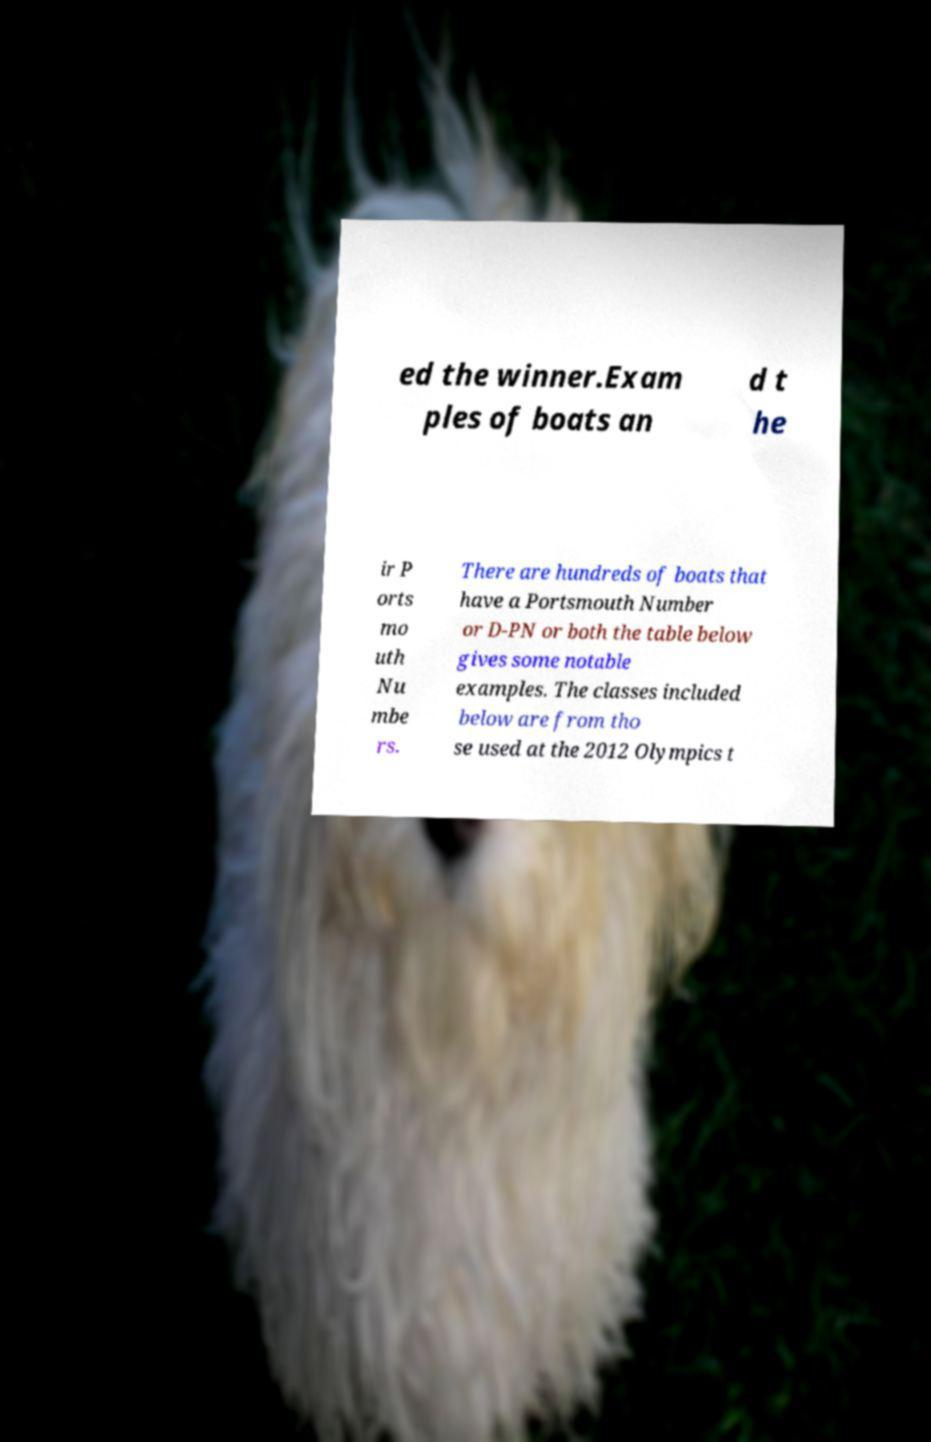I need the written content from this picture converted into text. Can you do that? ed the winner.Exam ples of boats an d t he ir P orts mo uth Nu mbe rs. There are hundreds of boats that have a Portsmouth Number or D-PN or both the table below gives some notable examples. The classes included below are from tho se used at the 2012 Olympics t 